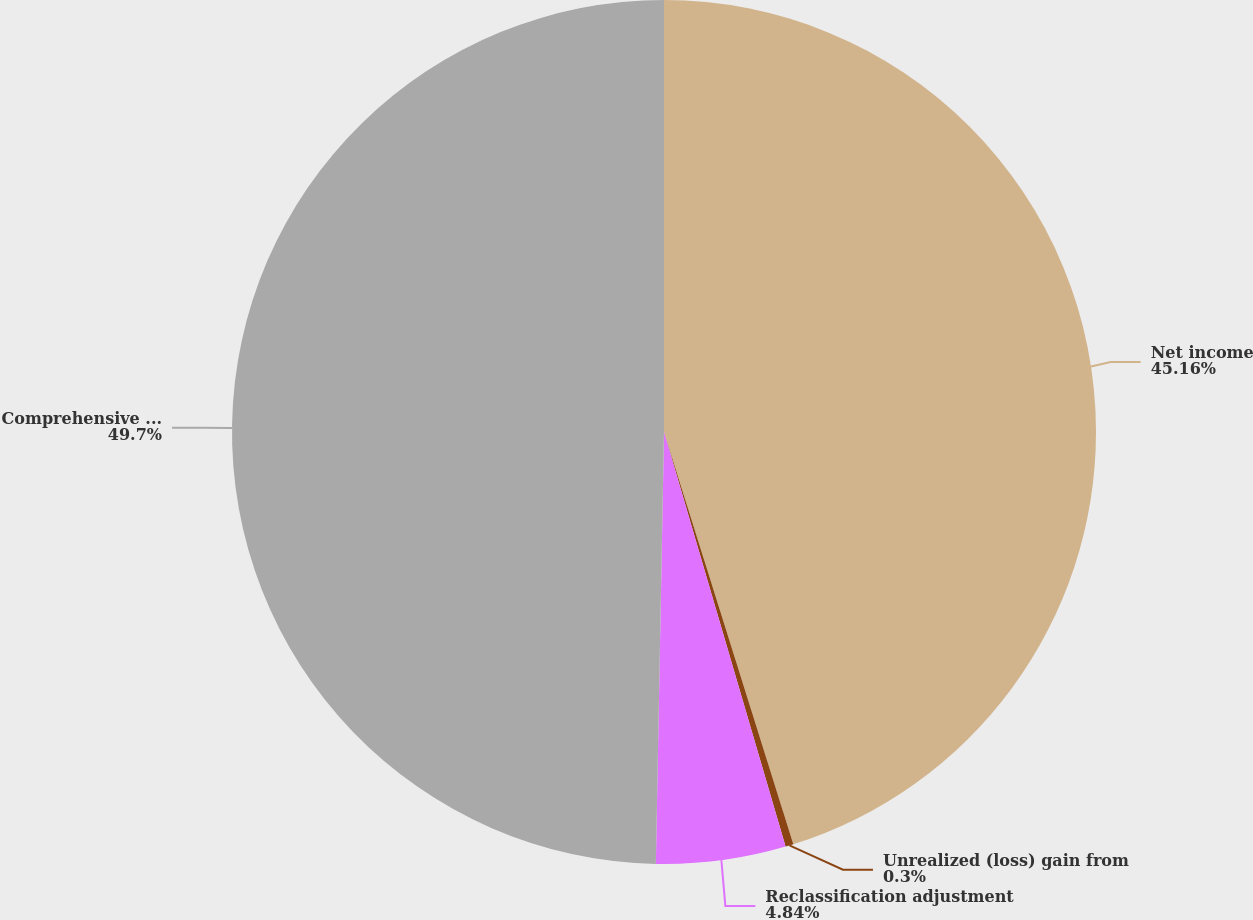Convert chart to OTSL. <chart><loc_0><loc_0><loc_500><loc_500><pie_chart><fcel>Net income<fcel>Unrealized (loss) gain from<fcel>Reclassification adjustment<fcel>Comprehensive income<nl><fcel>45.16%<fcel>0.3%<fcel>4.84%<fcel>49.7%<nl></chart> 